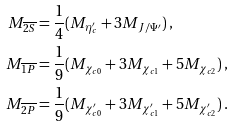Convert formula to latex. <formula><loc_0><loc_0><loc_500><loc_500>M _ { \overline { 2 S } } & = \frac { 1 } { 4 } ( M _ { \eta _ { c } ^ { \prime } } + 3 M _ { J / \Psi ^ { \prime } } ) \, , \\ M _ { \overline { 1 P } } & = \frac { 1 } { 9 } ( M _ { \chi _ { c 0 } } + 3 M _ { \chi _ { c 1 } } + 5 M _ { \chi _ { c 2 } } ) \, , \\ M _ { \overline { 2 P } } & = \frac { 1 } { 9 } ( M _ { \chi _ { c 0 } ^ { \prime } } + 3 M _ { \chi _ { c 1 } ^ { \prime } } + 5 M _ { \chi _ { c 2 } ^ { \prime } } ) \, .</formula> 